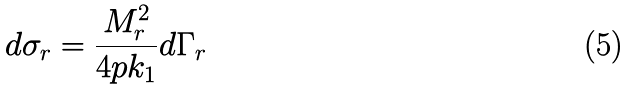<formula> <loc_0><loc_0><loc_500><loc_500>d \sigma _ { r } = \frac { M _ { r } ^ { 2 } } { 4 p k _ { 1 } } d \Gamma _ { r }</formula> 